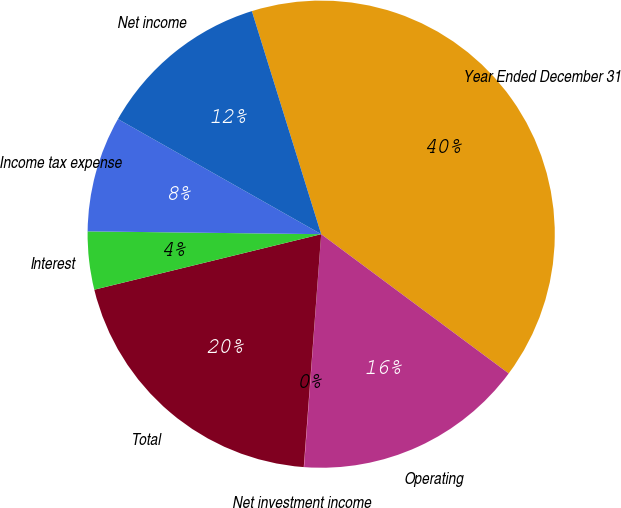Convert chart to OTSL. <chart><loc_0><loc_0><loc_500><loc_500><pie_chart><fcel>Year Ended December 31<fcel>Operating<fcel>Net investment income<fcel>Total<fcel>Interest<fcel>Income tax expense<fcel>Net income<nl><fcel>39.96%<fcel>16.0%<fcel>0.02%<fcel>19.99%<fcel>4.01%<fcel>8.01%<fcel>12.0%<nl></chart> 